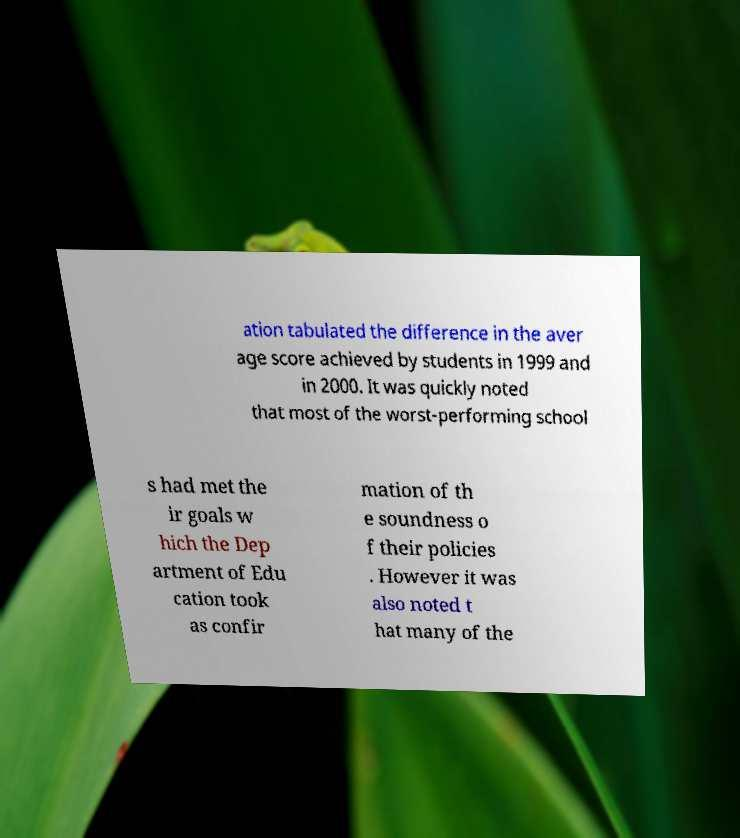What messages or text are displayed in this image? I need them in a readable, typed format. ation tabulated the difference in the aver age score achieved by students in 1999 and in 2000. It was quickly noted that most of the worst-performing school s had met the ir goals w hich the Dep artment of Edu cation took as confir mation of th e soundness o f their policies . However it was also noted t hat many of the 